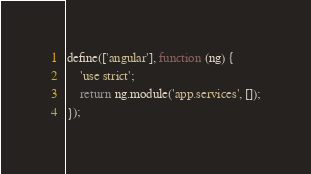Convert code to text. <code><loc_0><loc_0><loc_500><loc_500><_JavaScript_>define(['angular'], function (ng) {
    'use strict';
    return ng.module('app.services', []);
});
</code> 